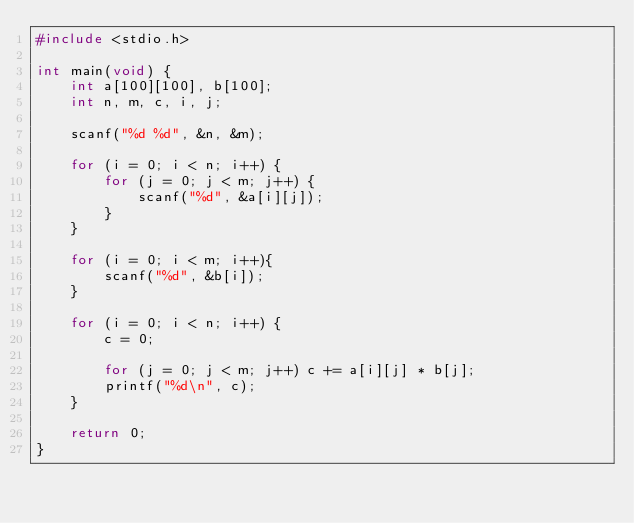Convert code to text. <code><loc_0><loc_0><loc_500><loc_500><_C_>#include <stdio.h>

int main(void) {
	int a[100][100], b[100];
	int n, m, c, i, j;
	
	scanf("%d %d", &n, &m);
	
	for (i = 0; i < n; i++) {
		for (j = 0; j < m; j++) {
			scanf("%d", &a[i][j]);
		}
	}
	
	for (i = 0; i < m; i++){
        scanf("%d", &b[i]);
    } 
	
	for (i = 0; i < n; i++) {
		c = 0;

		for (j = 0; j < m; j++) c += a[i][j] * b[j];
		printf("%d\n", c);
	}
	
	return 0;
}
</code> 